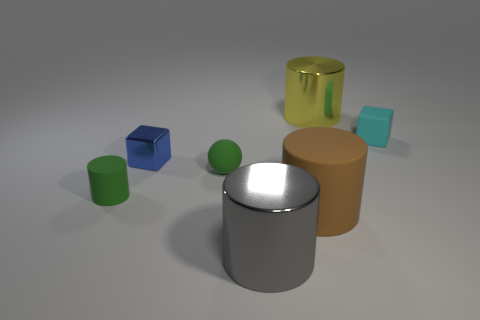What could be the purpose of these objects and how do they seem to be arranged? These objects appear to be three-dimensional models, possibly arranged for a graphical composition or visual experiment. The arrangement seems deliberate to demonstrate visual contrast, lighting effects, and reflections on different surfaces. 